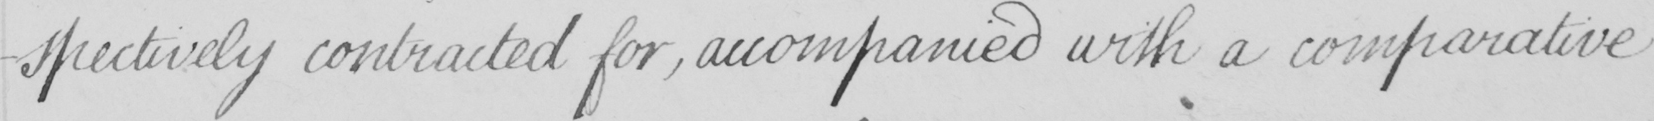Please transcribe the handwritten text in this image. -spectively contracted for , accompanied with a comparative 